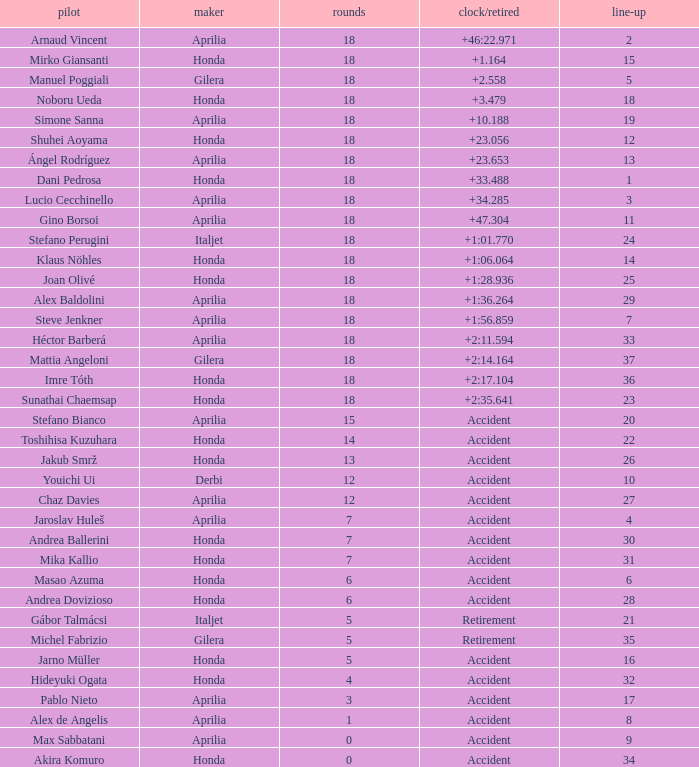What is the average number of laps with an accident time/retired, aprilia manufacturer and a grid of 27? 12.0. Could you parse the entire table? {'header': ['pilot', 'maker', 'rounds', 'clock/retired', 'line-up'], 'rows': [['Arnaud Vincent', 'Aprilia', '18', '+46:22.971', '2'], ['Mirko Giansanti', 'Honda', '18', '+1.164', '15'], ['Manuel Poggiali', 'Gilera', '18', '+2.558', '5'], ['Noboru Ueda', 'Honda', '18', '+3.479', '18'], ['Simone Sanna', 'Aprilia', '18', '+10.188', '19'], ['Shuhei Aoyama', 'Honda', '18', '+23.056', '12'], ['Ángel Rodríguez', 'Aprilia', '18', '+23.653', '13'], ['Dani Pedrosa', 'Honda', '18', '+33.488', '1'], ['Lucio Cecchinello', 'Aprilia', '18', '+34.285', '3'], ['Gino Borsoi', 'Aprilia', '18', '+47.304', '11'], ['Stefano Perugini', 'Italjet', '18', '+1:01.770', '24'], ['Klaus Nöhles', 'Honda', '18', '+1:06.064', '14'], ['Joan Olivé', 'Honda', '18', '+1:28.936', '25'], ['Alex Baldolini', 'Aprilia', '18', '+1:36.264', '29'], ['Steve Jenkner', 'Aprilia', '18', '+1:56.859', '7'], ['Héctor Barberá', 'Aprilia', '18', '+2:11.594', '33'], ['Mattia Angeloni', 'Gilera', '18', '+2:14.164', '37'], ['Imre Tóth', 'Honda', '18', '+2:17.104', '36'], ['Sunathai Chaemsap', 'Honda', '18', '+2:35.641', '23'], ['Stefano Bianco', 'Aprilia', '15', 'Accident', '20'], ['Toshihisa Kuzuhara', 'Honda', '14', 'Accident', '22'], ['Jakub Smrž', 'Honda', '13', 'Accident', '26'], ['Youichi Ui', 'Derbi', '12', 'Accident', '10'], ['Chaz Davies', 'Aprilia', '12', 'Accident', '27'], ['Jaroslav Huleš', 'Aprilia', '7', 'Accident', '4'], ['Andrea Ballerini', 'Honda', '7', 'Accident', '30'], ['Mika Kallio', 'Honda', '7', 'Accident', '31'], ['Masao Azuma', 'Honda', '6', 'Accident', '6'], ['Andrea Dovizioso', 'Honda', '6', 'Accident', '28'], ['Gábor Talmácsi', 'Italjet', '5', 'Retirement', '21'], ['Michel Fabrizio', 'Gilera', '5', 'Retirement', '35'], ['Jarno Müller', 'Honda', '5', 'Accident', '16'], ['Hideyuki Ogata', 'Honda', '4', 'Accident', '32'], ['Pablo Nieto', 'Aprilia', '3', 'Accident', '17'], ['Alex de Angelis', 'Aprilia', '1', 'Accident', '8'], ['Max Sabbatani', 'Aprilia', '0', 'Accident', '9'], ['Akira Komuro', 'Honda', '0', 'Accident', '34']]} 